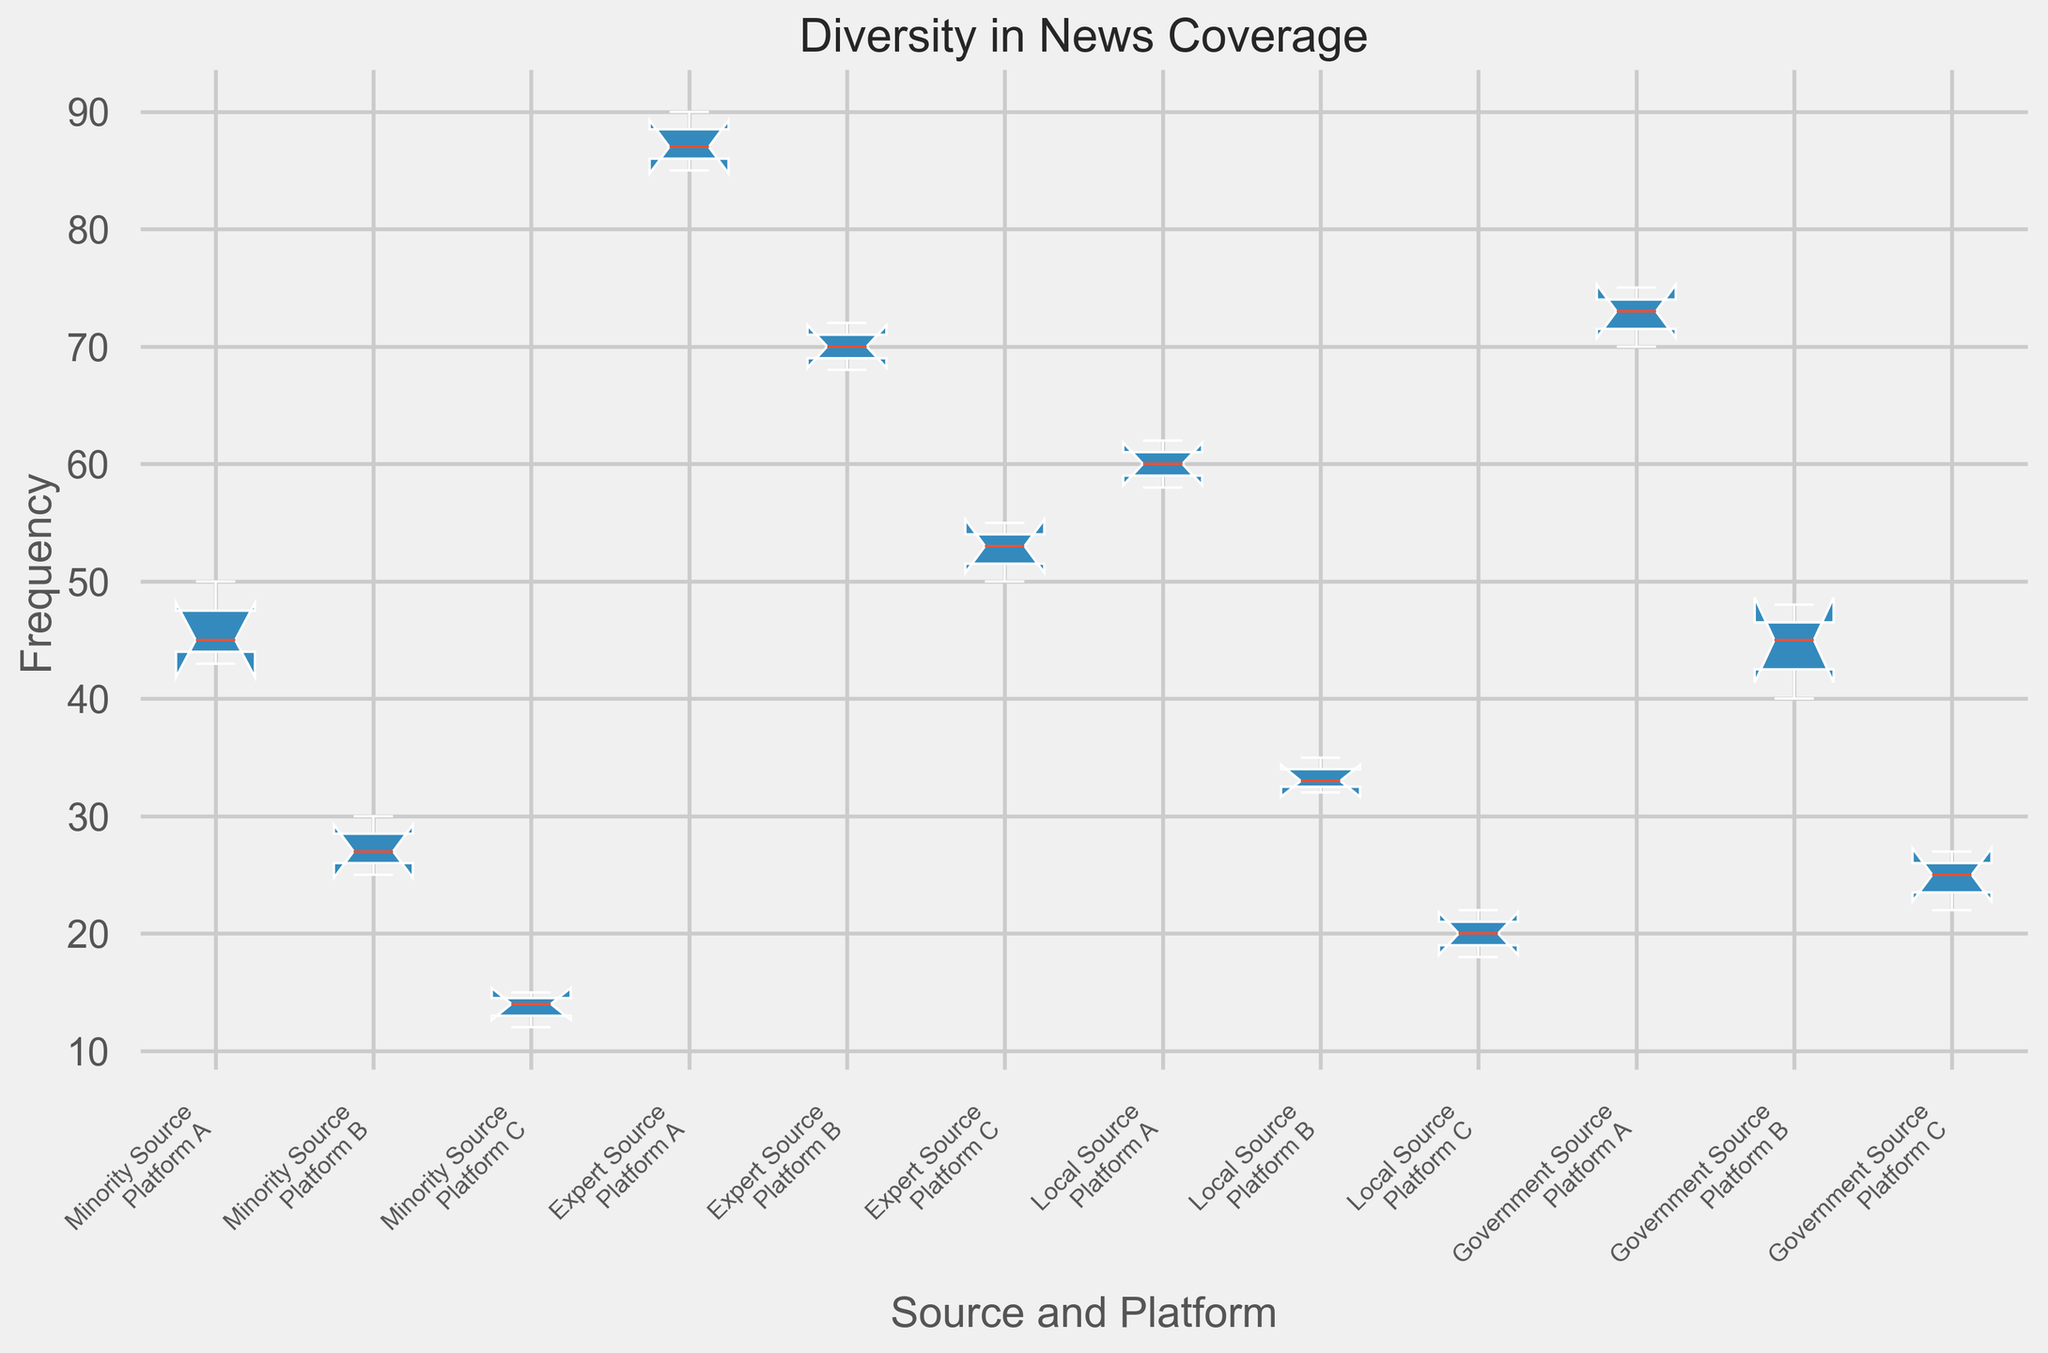Which platform has the highest median frequency for Expert Sources? The box plot shows the median values represented by the line within the box for each category. Looking at the box for Expert Sources across all platforms, Platform A has the highest median frequency.
Answer: Platform A Compare the interquartile range (IQR) of Minority Sources between Platform A and Platform B. Which platform has a larger IQR? The IQR is depicted by the height of the box in the plot. The box for Minority Sources in Platform A is taller compared to Platform B, indicating a larger IQR.
Answer: Platform A Which source type has the smallest variation in frequency on Platform C? The box representing Local Sources on Platform C has the smallest height, indicating the least variation in frequency.
Answer: Local Source Is the median frequency of Government Sources higher on Platform A or Platform B? By examining the line within the boxes for Government Sources, Platform A has a median value that is higher than Platform B.
Answer: Platform A Which platform shows the greatest frequency of Minority Sources, based on the upper whisker of the box plot? The upper whisker represents the maximum non-outlier value. For Minority Sources, Platform A has the highest upper whisker value.
Answer: Platform A Compare the median frequencies of Local Sources and Government Sources on Platform B. Which one is higher? The median is the line within the box. For Platform B, the median frequency of Local Sources appears lower than that of Government Sources.
Answer: Government Sources What is the range of frequencies for Expert Sources on Platform C? The range is calculated by subtracting the minimum value from the maximum value, indicated by the lower and upper whiskers. For Expert Sources on Platform C, the range is 55 - 50 = 5.
Answer: 5 Does Platform C have a higher median frequency of any source type compared to Platform B? By examining the median lines within the boxes, Platform B has higher medians than Platform C for all source types shown.
Answer: No Which source and platform combination exhibits the most outliers? The plot shows outliers as individual points beyond the whiskers. Minority Sources on Platform A and Expert Sources on Platform A both exhibit more visible outliers. Looking closer, Minority Sources on Platform A has slightly more.
Answer: Minority Source, Platform A For Platform A, which source type appears to have the widest distribution of frequencies? The widest distribution is indicated by the overall height from the bottom whisker to the top whisker. For Platform A, Expert Sources have the widest distribution.
Answer: Expert Sources 